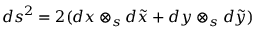<formula> <loc_0><loc_0><loc_500><loc_500>d s ^ { 2 } = 2 ( d x \otimes _ { s } d \tilde { x } + d y \otimes _ { s } d \tilde { y } )</formula> 